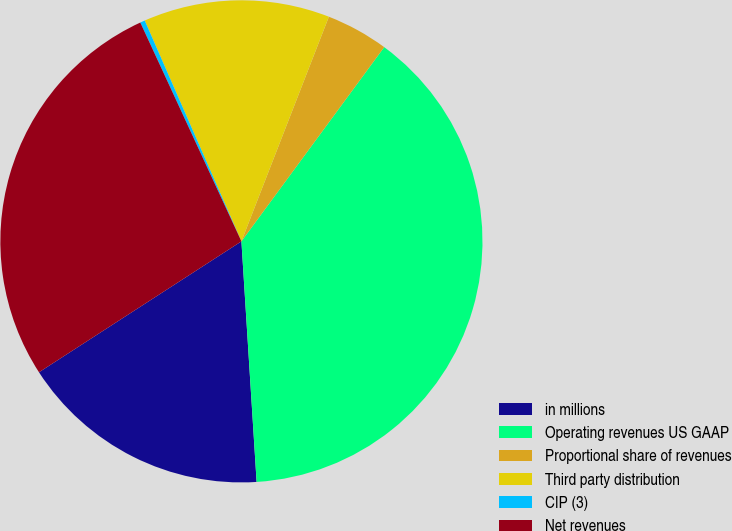<chart> <loc_0><loc_0><loc_500><loc_500><pie_chart><fcel>in millions<fcel>Operating revenues US GAAP<fcel>Proportional share of revenues<fcel>Third party distribution<fcel>CIP (3)<fcel>Net revenues<nl><fcel>16.87%<fcel>38.91%<fcel>4.18%<fcel>12.48%<fcel>0.32%<fcel>27.25%<nl></chart> 